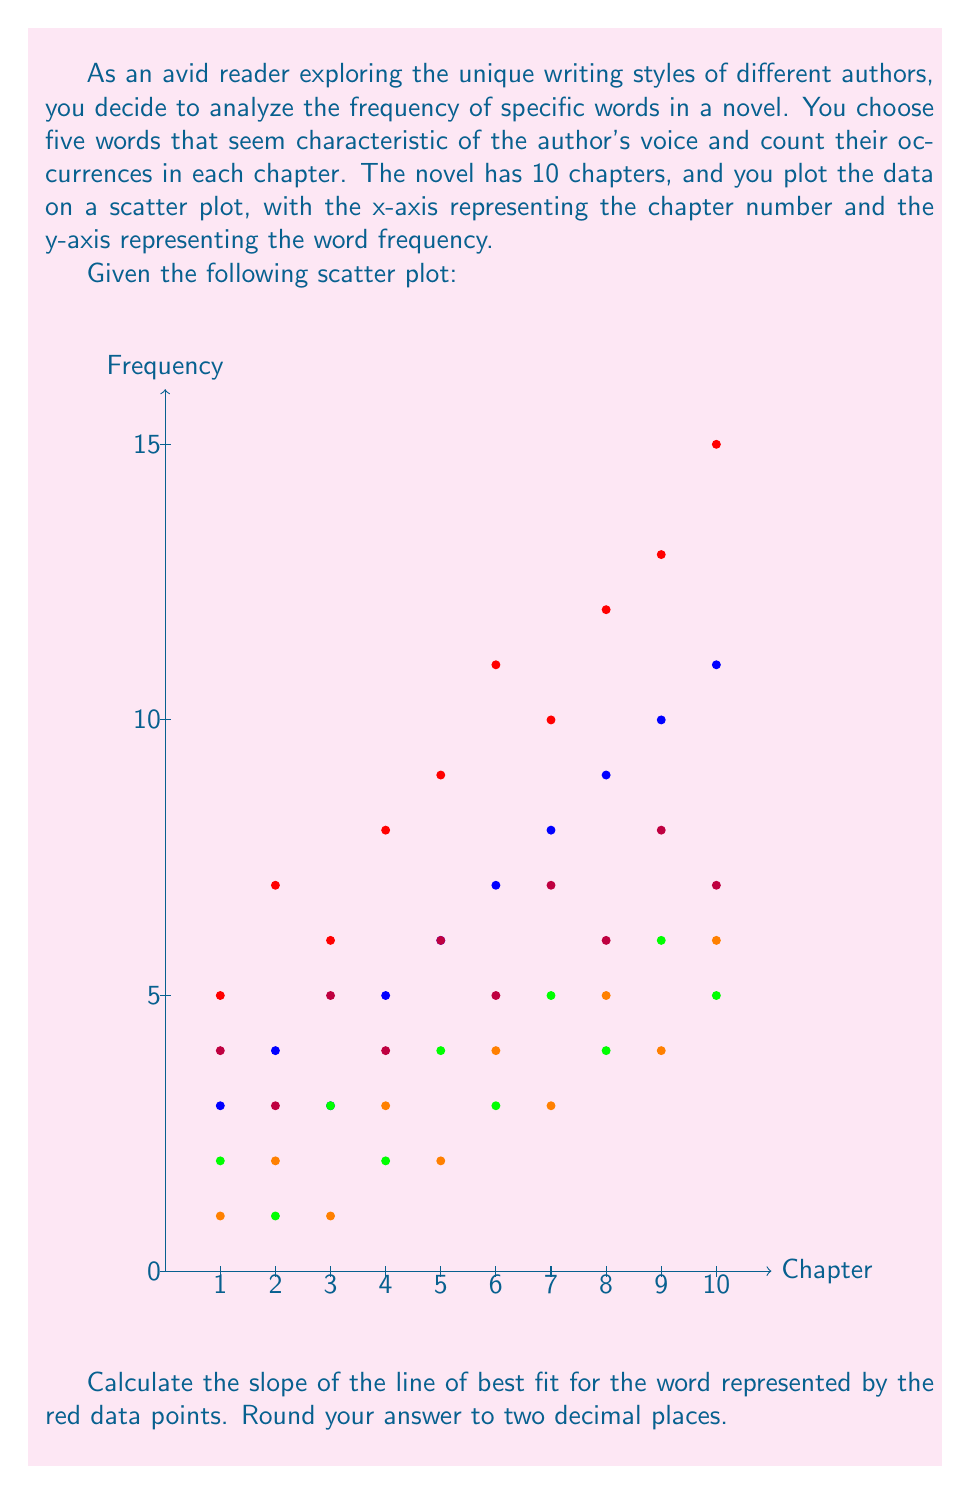Teach me how to tackle this problem. To calculate the slope of the line of best fit for the red data points, we'll use the formula for the slope in a linear regression model:

$$ m = \frac{n\sum xy - \sum x \sum y}{n\sum x^2 - (\sum x)^2} $$

Where:
$n$ is the number of data points
$x$ represents the chapter numbers
$y$ represents the word frequencies

Step 1: Calculate the required sums:
$n = 10$
$\sum x = 1 + 2 + 3 + 4 + 5 + 6 + 7 + 8 + 9 + 10 = 55$
$\sum y = 5 + 7 + 6 + 8 + 9 + 11 + 10 + 12 + 13 + 15 = 96$
$\sum xy = 1(5) + 2(7) + 3(6) + 4(8) + 5(9) + 6(11) + 7(10) + 8(12) + 9(13) + 10(15) = 655$
$\sum x^2 = 1^2 + 2^2 + 3^2 + 4^2 + 5^2 + 6^2 + 7^2 + 8^2 + 9^2 + 10^2 = 385$

Step 2: Substitute these values into the slope formula:

$$ m = \frac{10(655) - 55(96)}{10(385) - 55^2} $$

Step 3: Simplify:

$$ m = \frac{6550 - 5280}{3850 - 3025} = \frac{1270}{825} $$

Step 4: Calculate and round to two decimal places:

$$ m \approx 1.54 $$
Answer: 1.54 